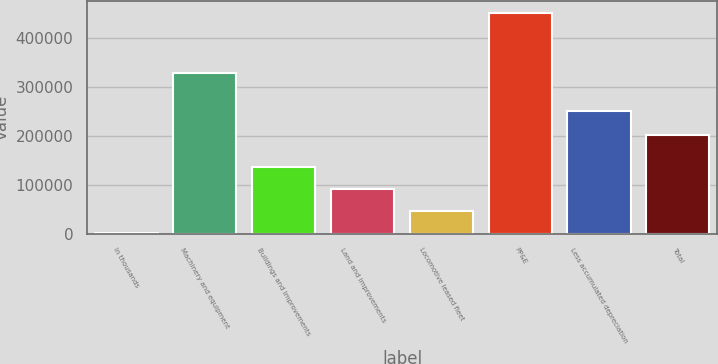Convert chart. <chart><loc_0><loc_0><loc_500><loc_500><bar_chart><fcel>In thousands<fcel>Machinery and equipment<fcel>Buildings and improvements<fcel>Land and improvements<fcel>Locomotive leased fleet<fcel>PP&E<fcel>Less accumulated depreciation<fcel>Total<nl><fcel>2009<fcel>328172<fcel>137005<fcel>92006.4<fcel>47007.7<fcel>451996<fcel>250289<fcel>201707<nl></chart> 